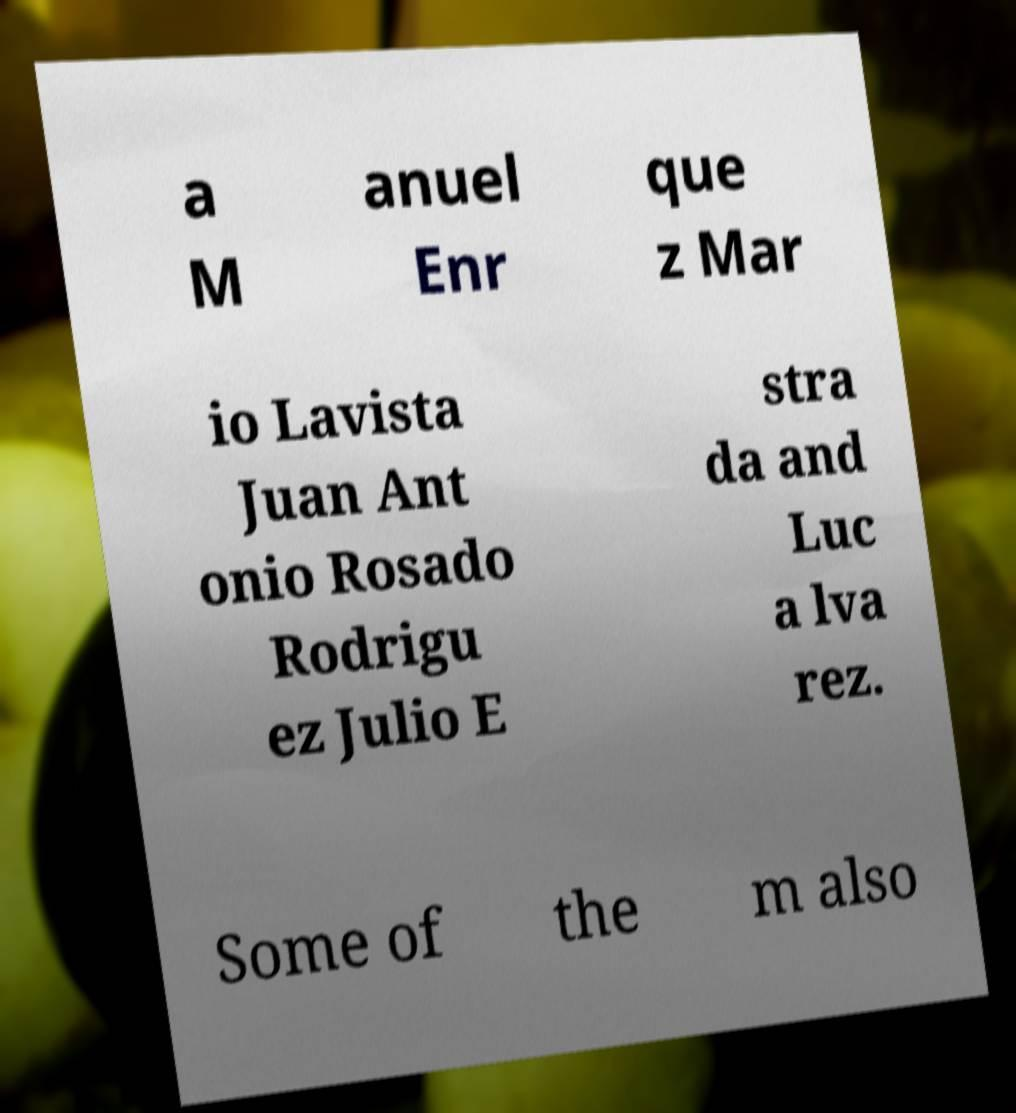Could you extract and type out the text from this image? a M anuel Enr que z Mar io Lavista Juan Ant onio Rosado Rodrigu ez Julio E stra da and Luc a lva rez. Some of the m also 